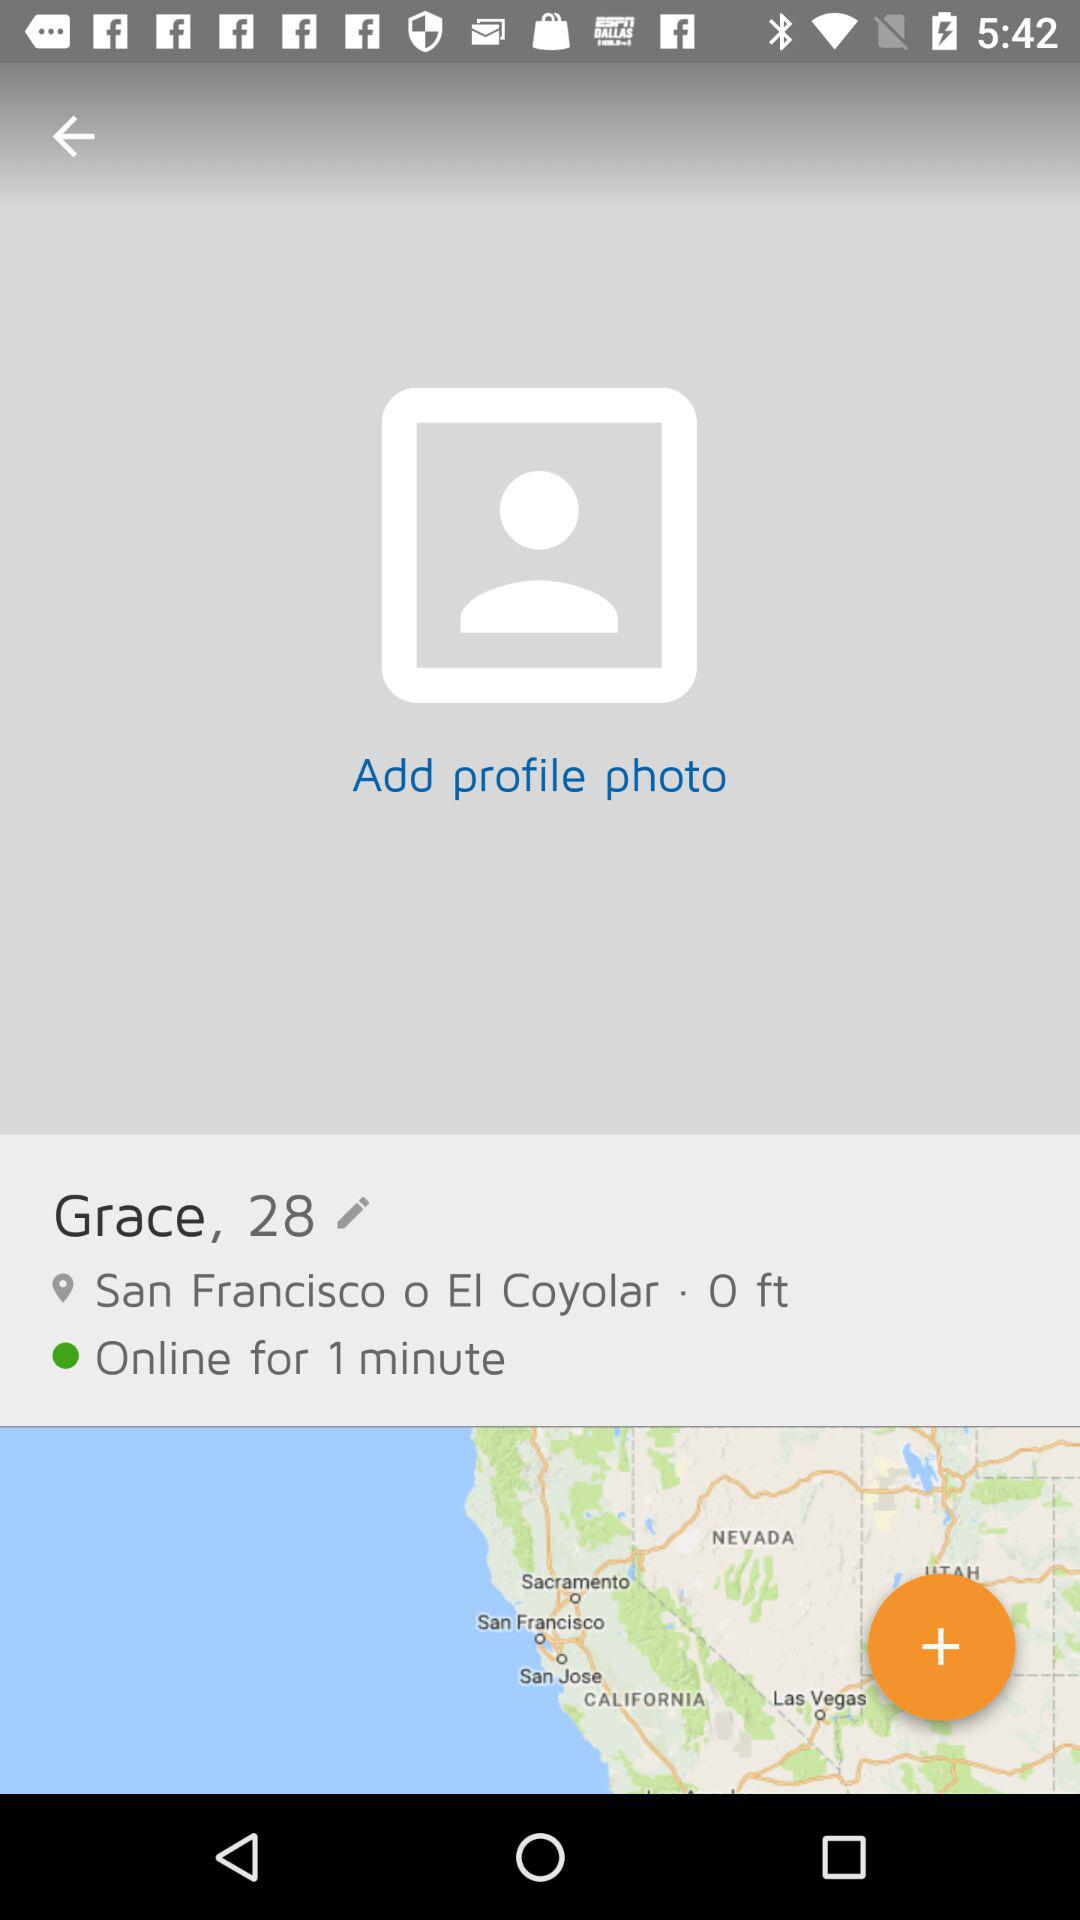How many minutes has the user been online for?
Answer the question using a single word or phrase. 1 